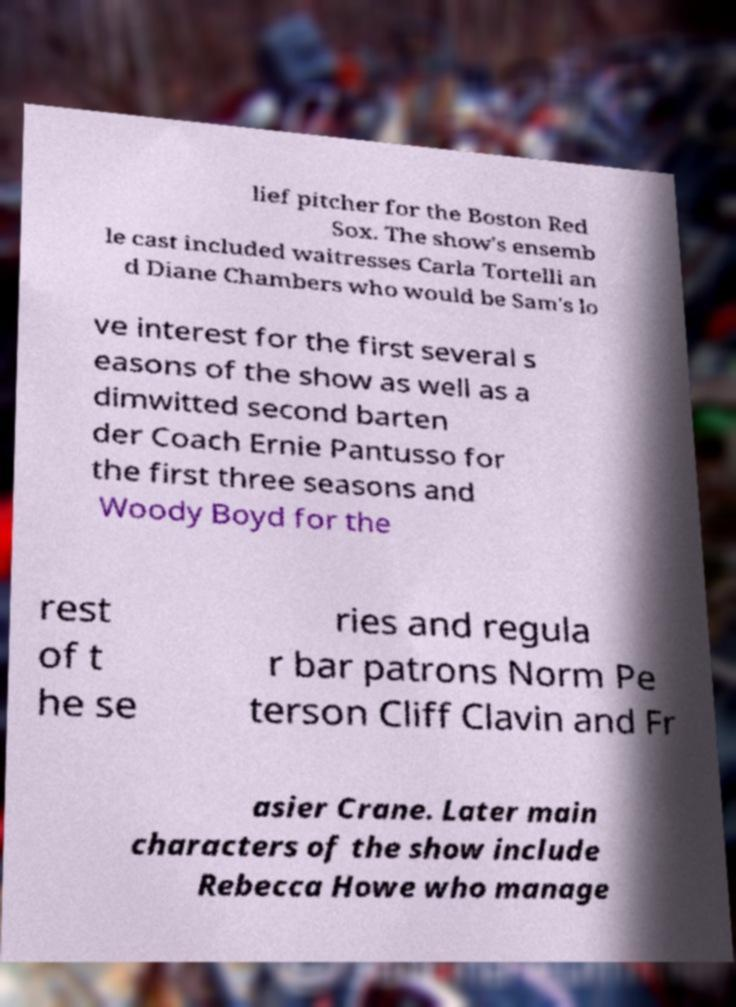Please identify and transcribe the text found in this image. lief pitcher for the Boston Red Sox. The show's ensemb le cast included waitresses Carla Tortelli an d Diane Chambers who would be Sam's lo ve interest for the first several s easons of the show as well as a dimwitted second barten der Coach Ernie Pantusso for the first three seasons and Woody Boyd for the rest of t he se ries and regula r bar patrons Norm Pe terson Cliff Clavin and Fr asier Crane. Later main characters of the show include Rebecca Howe who manage 